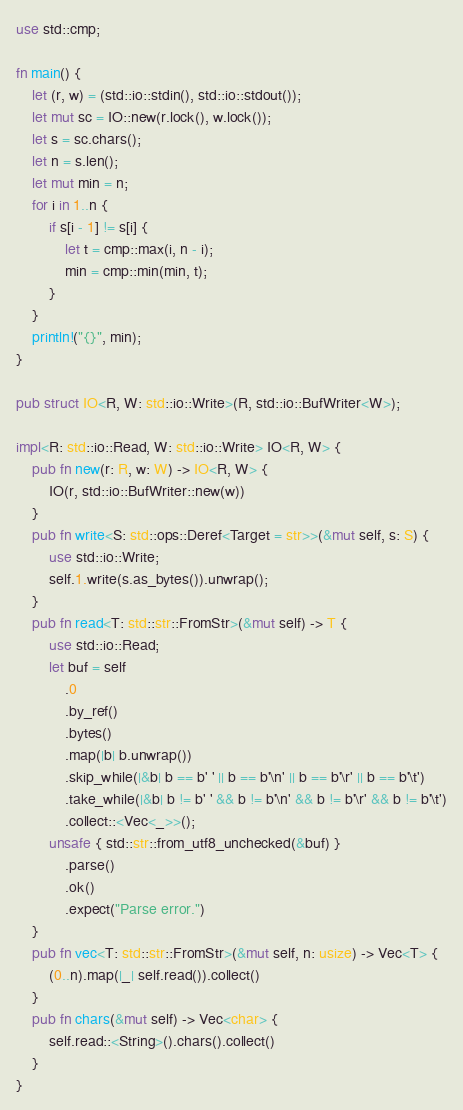<code> <loc_0><loc_0><loc_500><loc_500><_Rust_>use std::cmp;

fn main() {
    let (r, w) = (std::io::stdin(), std::io::stdout());
    let mut sc = IO::new(r.lock(), w.lock());
    let s = sc.chars();
    let n = s.len();
    let mut min = n;
    for i in 1..n {
        if s[i - 1] != s[i] {
            let t = cmp::max(i, n - i);
            min = cmp::min(min, t);
        }
    }
    println!("{}", min);
}

pub struct IO<R, W: std::io::Write>(R, std::io::BufWriter<W>);

impl<R: std::io::Read, W: std::io::Write> IO<R, W> {
    pub fn new(r: R, w: W) -> IO<R, W> {
        IO(r, std::io::BufWriter::new(w))
    }
    pub fn write<S: std::ops::Deref<Target = str>>(&mut self, s: S) {
        use std::io::Write;
        self.1.write(s.as_bytes()).unwrap();
    }
    pub fn read<T: std::str::FromStr>(&mut self) -> T {
        use std::io::Read;
        let buf = self
            .0
            .by_ref()
            .bytes()
            .map(|b| b.unwrap())
            .skip_while(|&b| b == b' ' || b == b'\n' || b == b'\r' || b == b'\t')
            .take_while(|&b| b != b' ' && b != b'\n' && b != b'\r' && b != b'\t')
            .collect::<Vec<_>>();
        unsafe { std::str::from_utf8_unchecked(&buf) }
            .parse()
            .ok()
            .expect("Parse error.")
    }
    pub fn vec<T: std::str::FromStr>(&mut self, n: usize) -> Vec<T> {
        (0..n).map(|_| self.read()).collect()
    }
    pub fn chars(&mut self) -> Vec<char> {
        self.read::<String>().chars().collect()
    }
}
</code> 